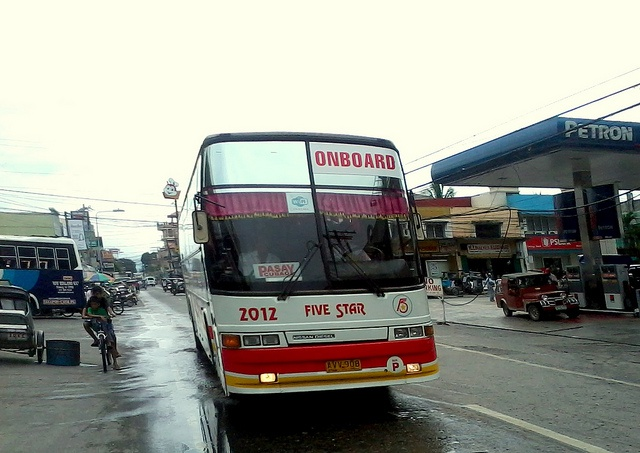Describe the objects in this image and their specific colors. I can see bus in ivory, black, darkgray, beige, and gray tones, bus in ivory, black, gray, darkblue, and blue tones, car in ivory, black, gray, maroon, and darkgray tones, car in ivory, black, gray, darkgray, and beige tones, and people in ivory, purple, and black tones in this image. 